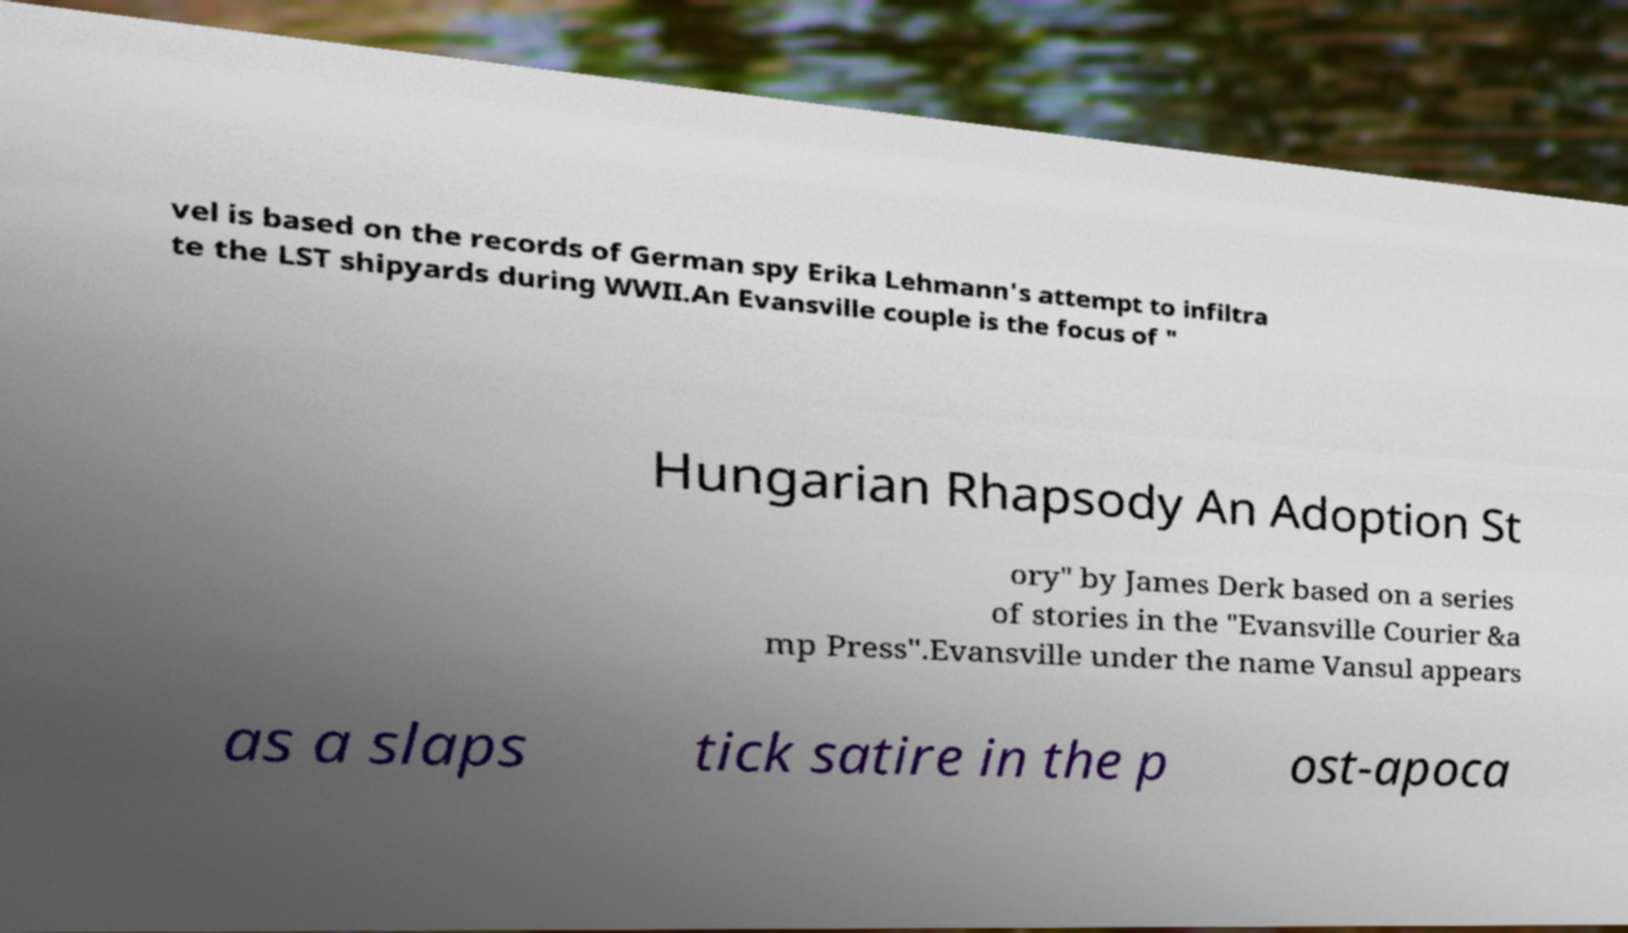Could you assist in decoding the text presented in this image and type it out clearly? vel is based on the records of German spy Erika Lehmann's attempt to infiltra te the LST shipyards during WWII.An Evansville couple is the focus of " Hungarian Rhapsody An Adoption St ory" by James Derk based on a series of stories in the "Evansville Courier &a mp Press".Evansville under the name Vansul appears as a slaps tick satire in the p ost-apoca 